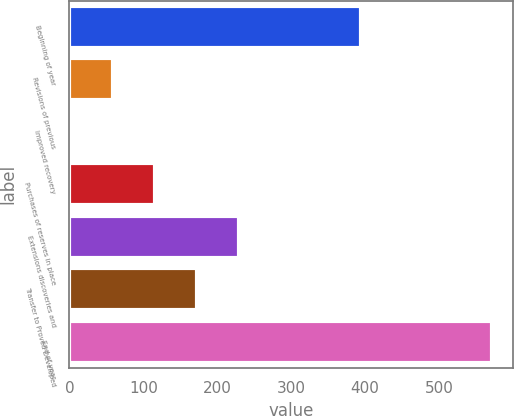Convert chart to OTSL. <chart><loc_0><loc_0><loc_500><loc_500><bar_chart><fcel>Beginning of year<fcel>Revisions of previous<fcel>Improved recovery<fcel>Purchases of reserves in place<fcel>Extensions discoveries and<fcel>Transfer to Proved Developed<fcel>End of year<nl><fcel>395<fcel>58.9<fcel>2<fcel>115.8<fcel>229.6<fcel>172.7<fcel>571<nl></chart> 